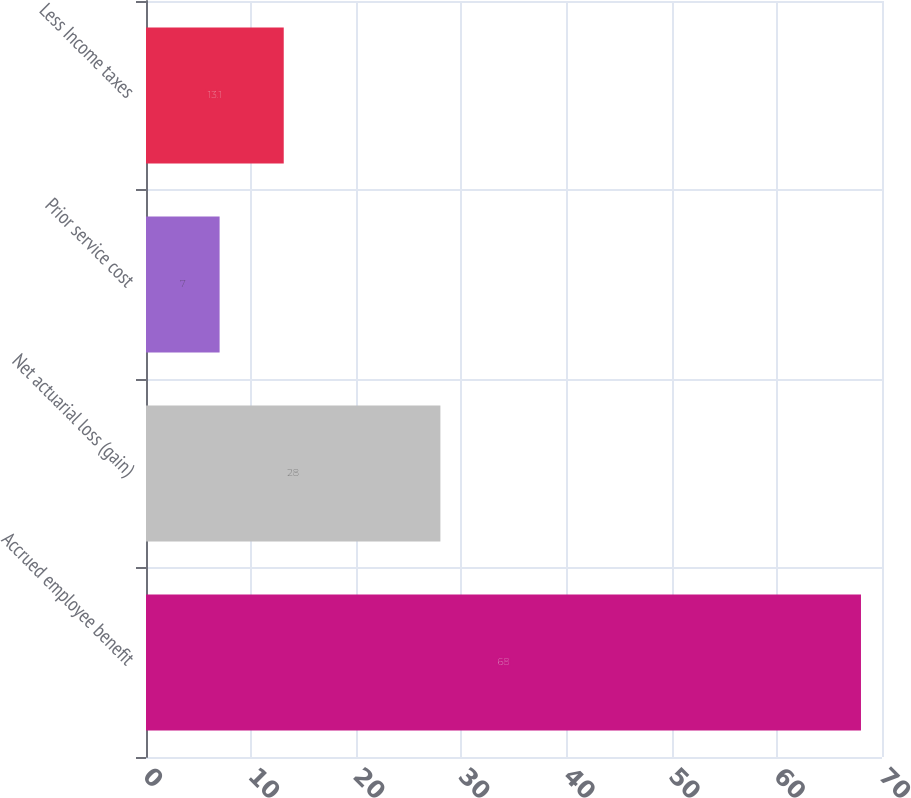Convert chart to OTSL. <chart><loc_0><loc_0><loc_500><loc_500><bar_chart><fcel>Accrued employee benefit<fcel>Net actuarial loss (gain)<fcel>Prior service cost<fcel>Less Income taxes<nl><fcel>68<fcel>28<fcel>7<fcel>13.1<nl></chart> 